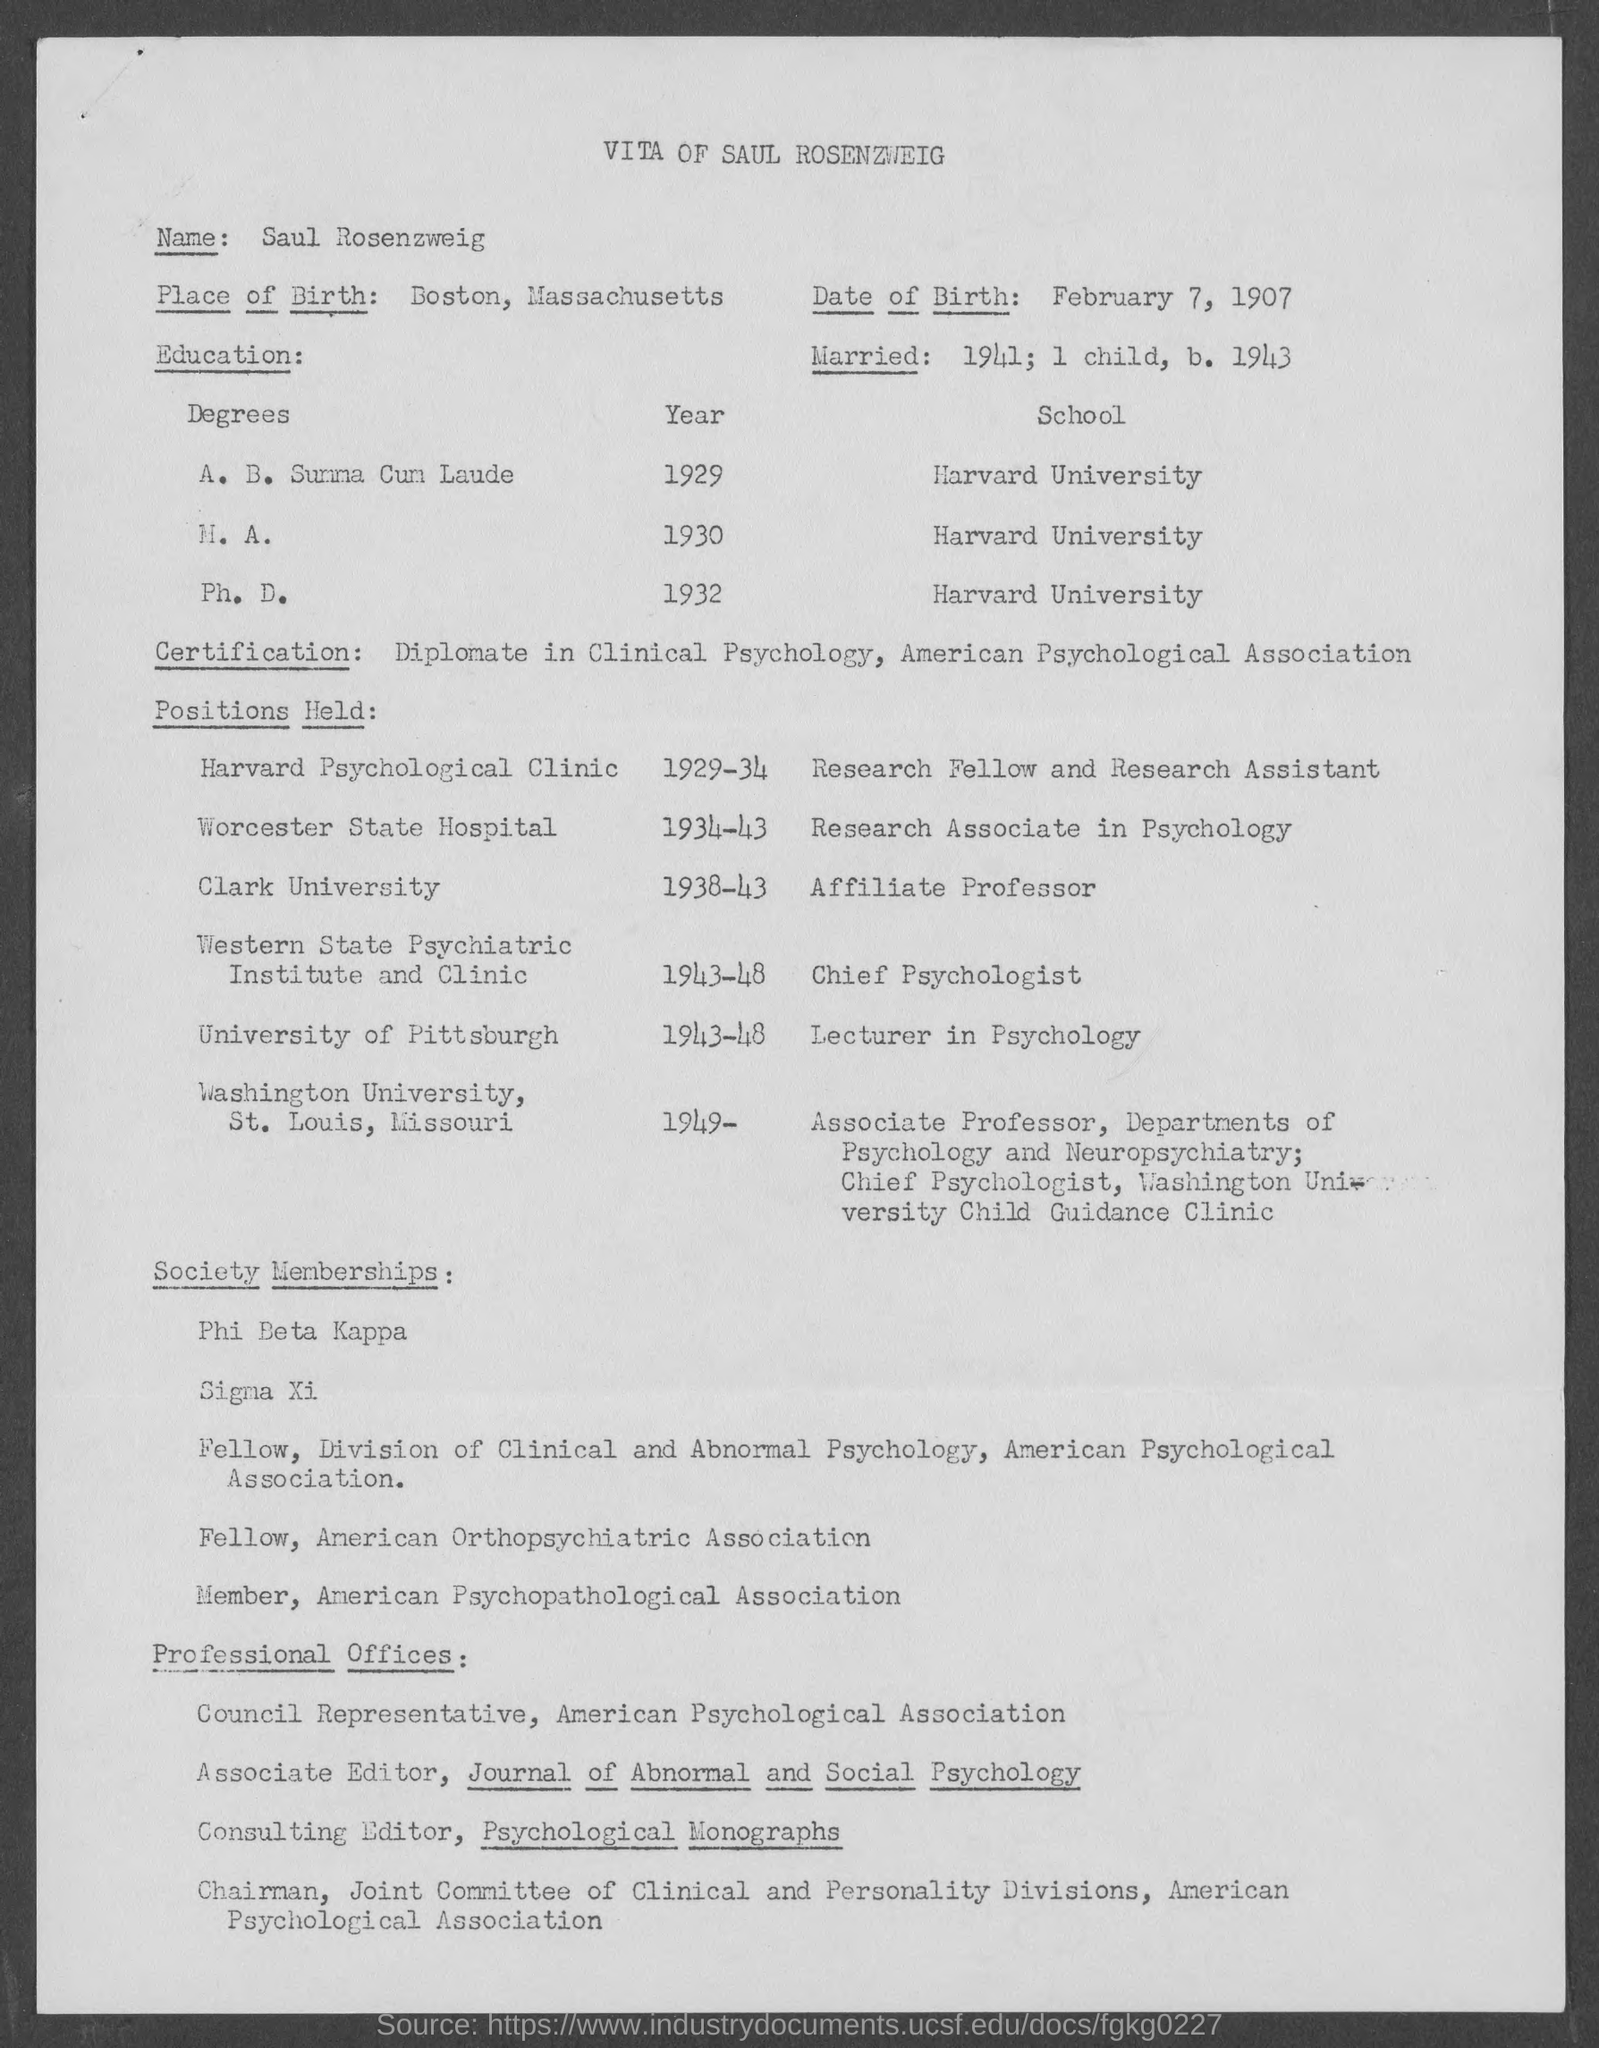Identify some key points in this picture. The date of birth is February 7, 1907. The place of birth is Boston, Massachusetts. The individual received their Ph.D. in Harvard University. In the year 1941, he was married. The profile of Saul Rosenzweig, mentioned in the document, is... 